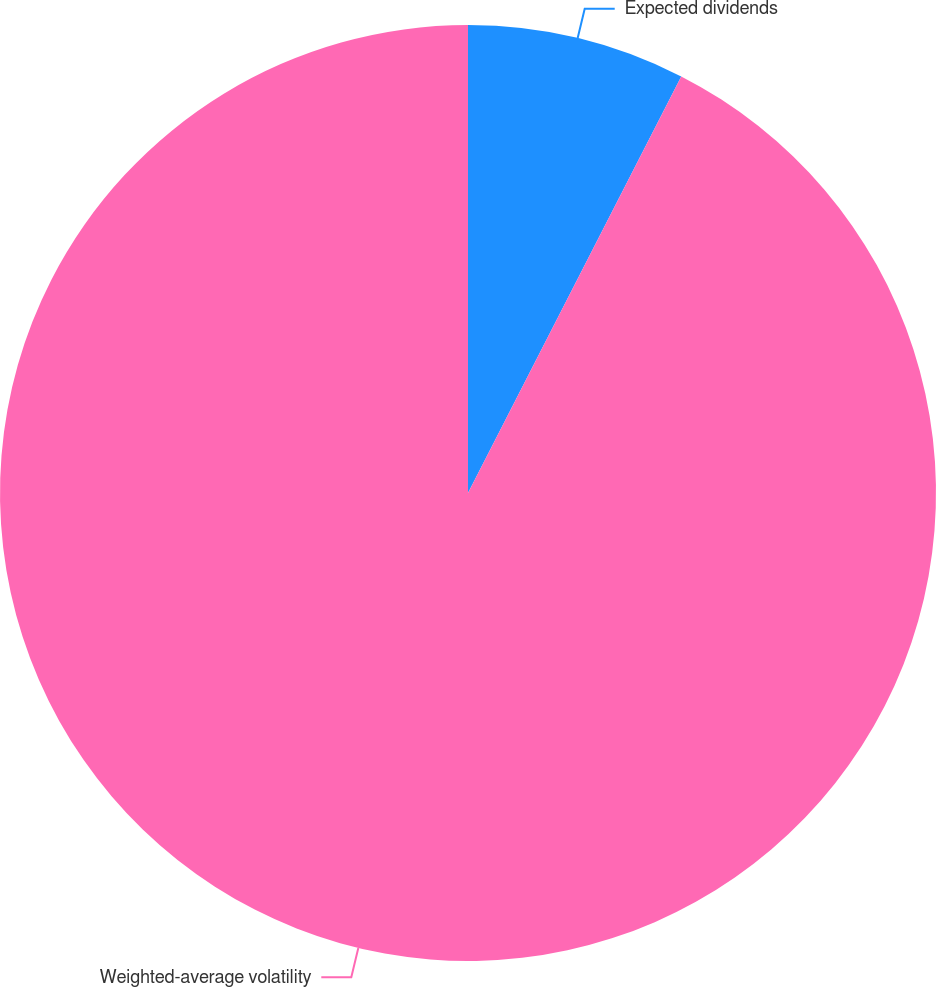Convert chart to OTSL. <chart><loc_0><loc_0><loc_500><loc_500><pie_chart><fcel>Expected dividends<fcel>Weighted-average volatility<nl><fcel>7.53%<fcel>92.47%<nl></chart> 